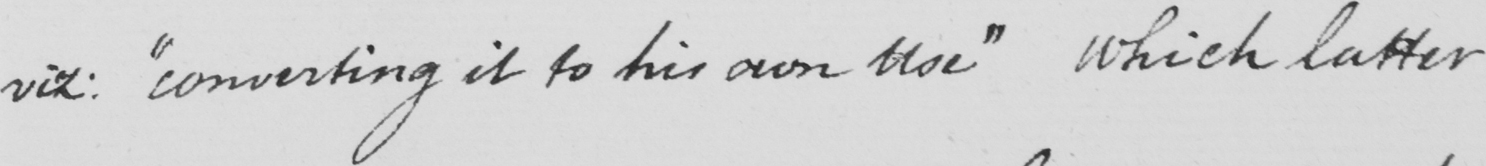Please provide the text content of this handwritten line. viz :   " converting it to his own use "  which latter 